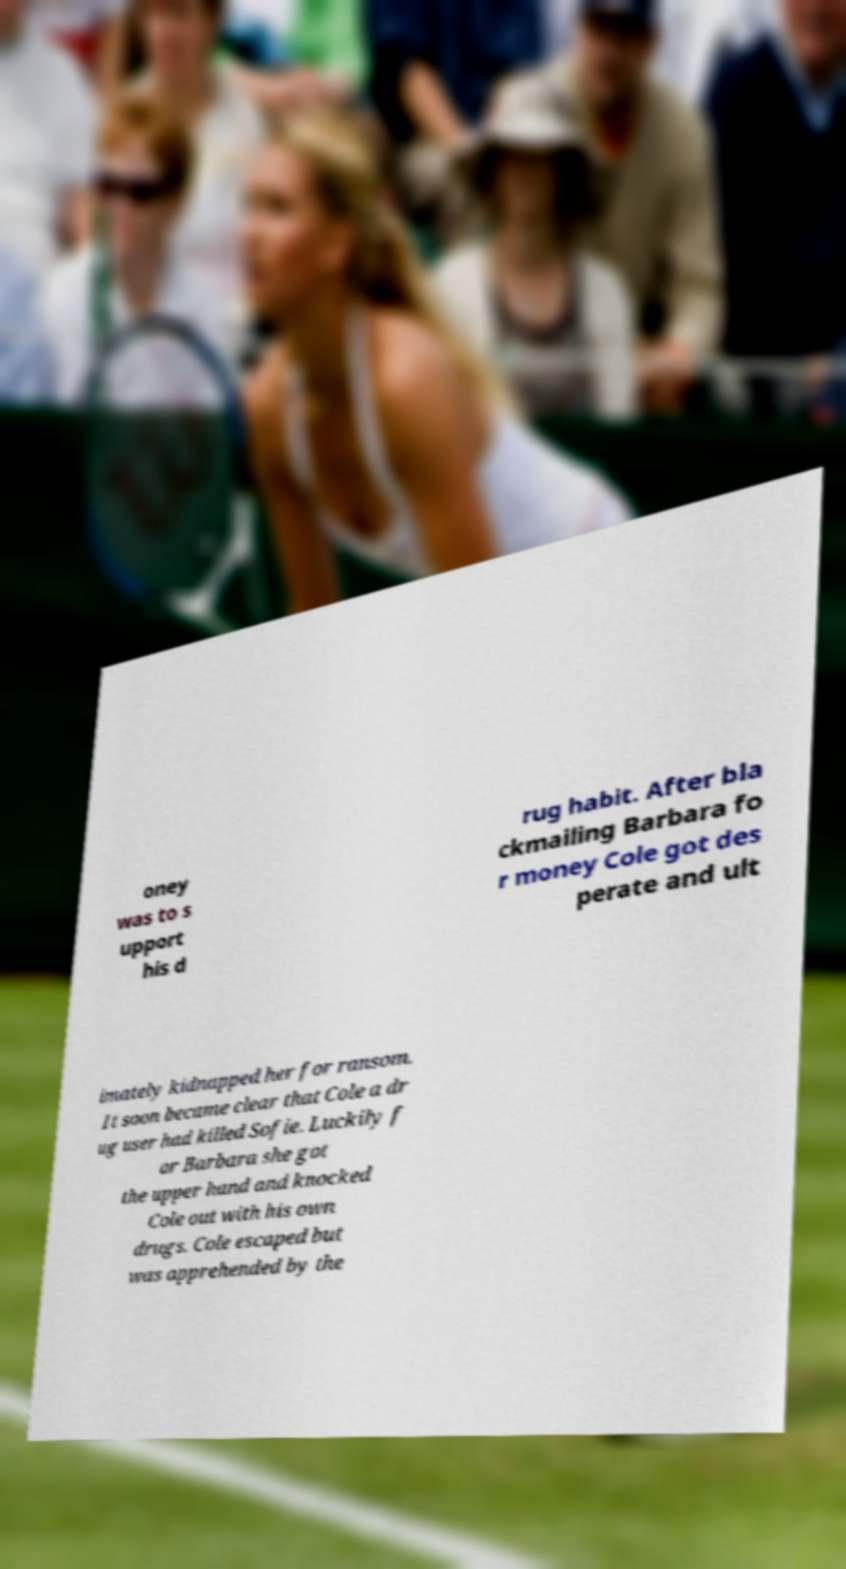Could you extract and type out the text from this image? oney was to s upport his d rug habit. After bla ckmailing Barbara fo r money Cole got des perate and ult imately kidnapped her for ransom. It soon became clear that Cole a dr ug user had killed Sofie. Luckily f or Barbara she got the upper hand and knocked Cole out with his own drugs. Cole escaped but was apprehended by the 